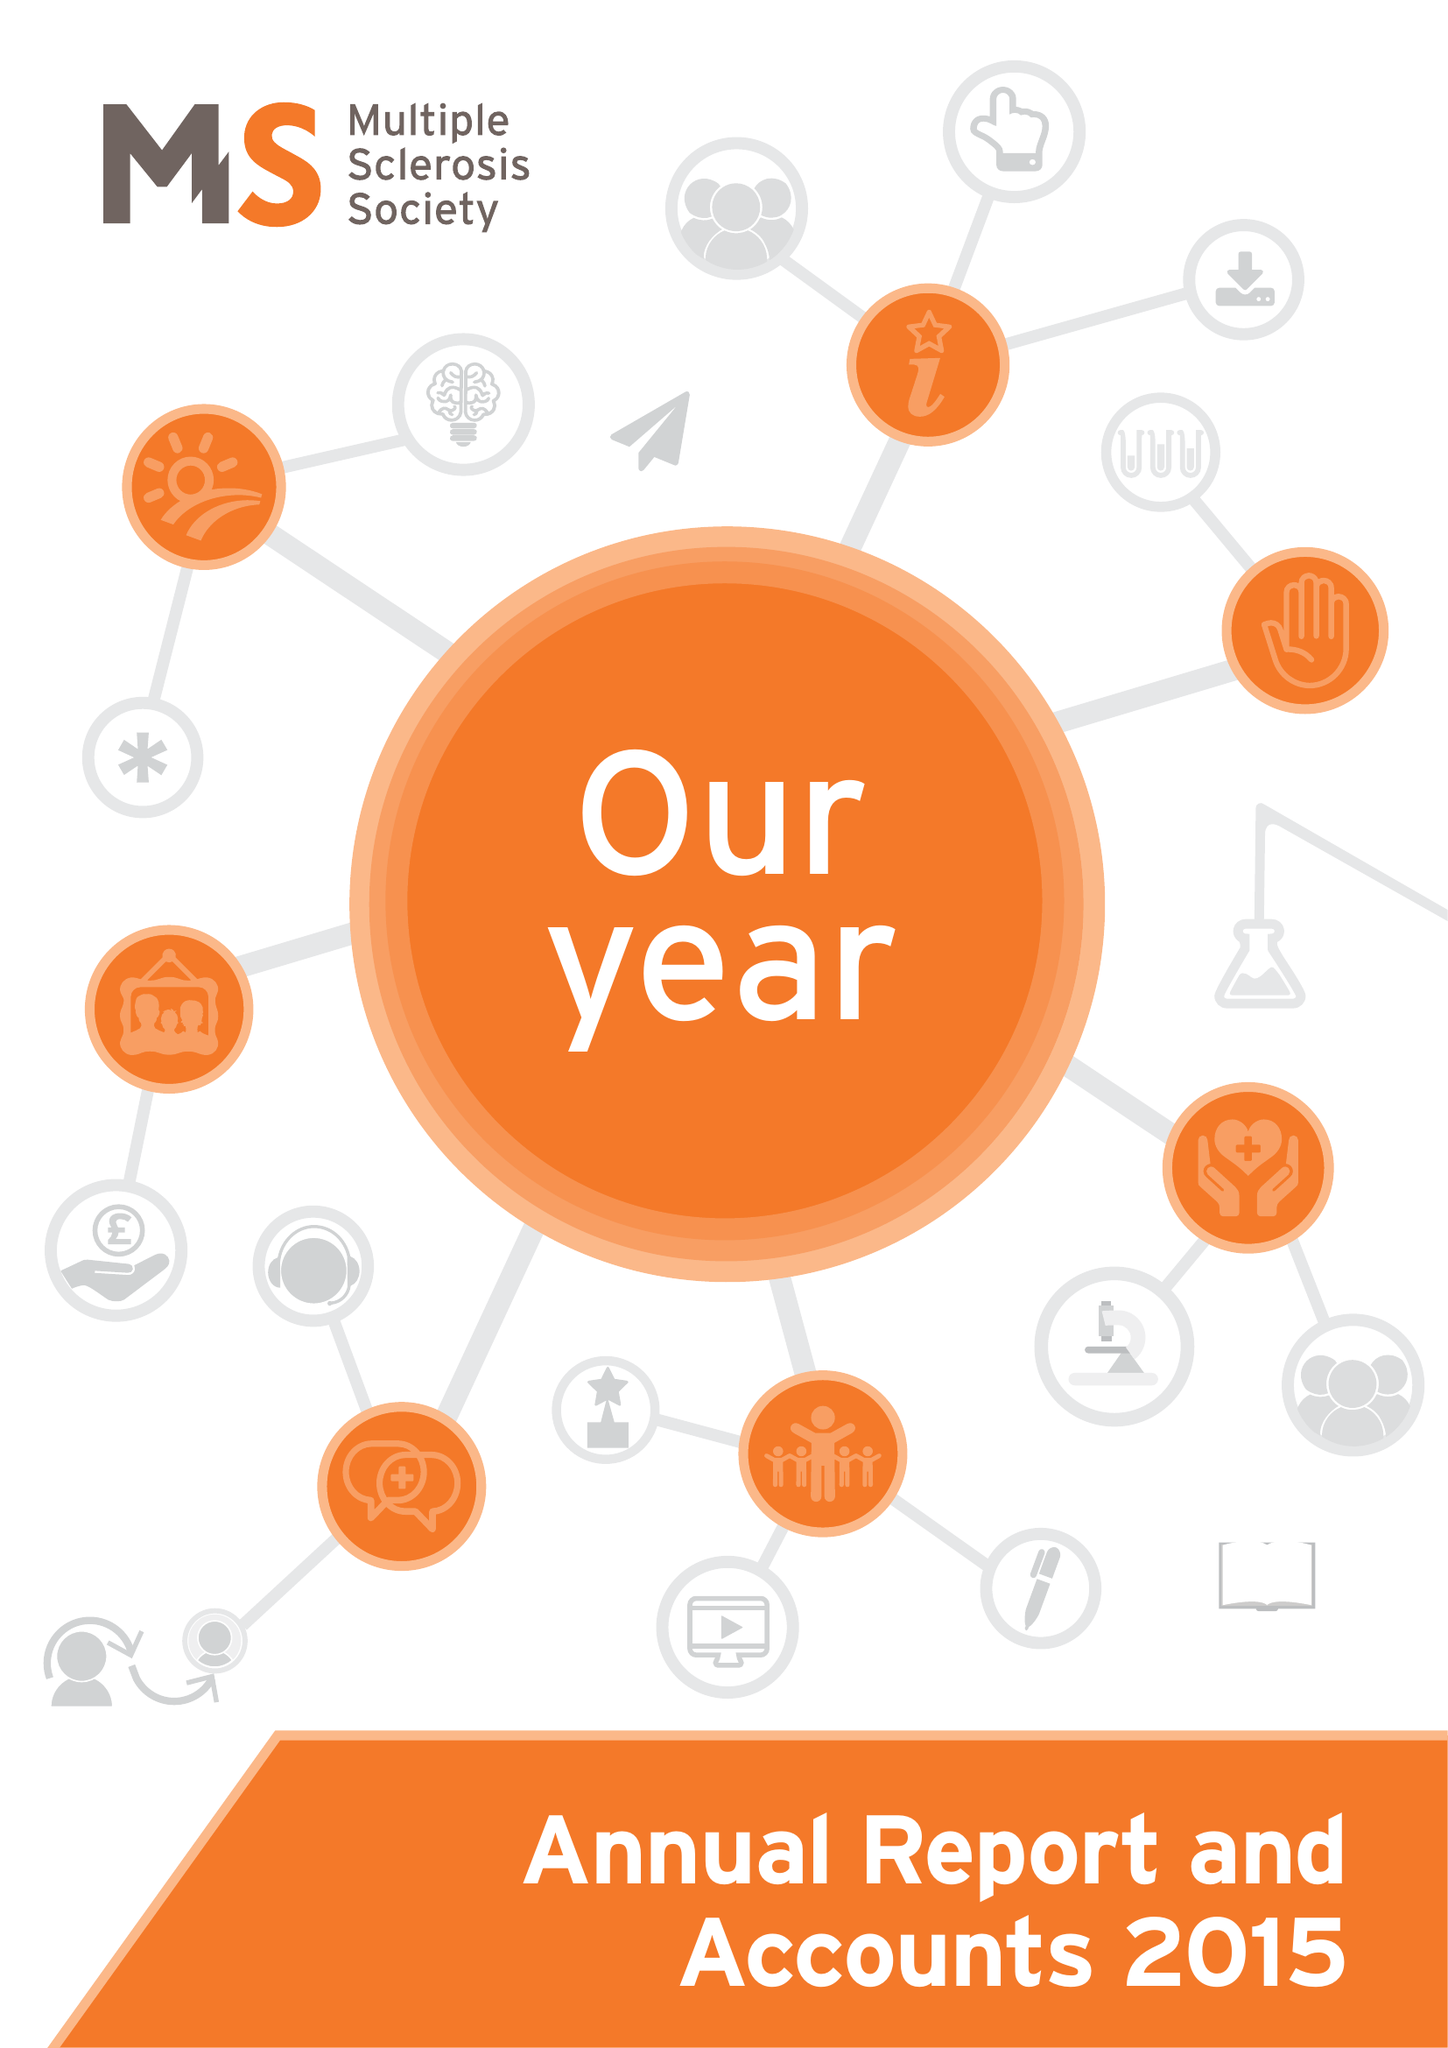What is the value for the address__street_line?
Answer the question using a single word or phrase. 372 EDGWARE ROAD 